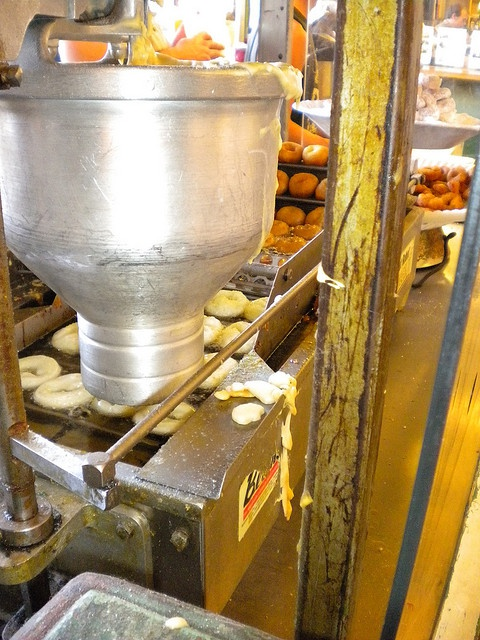Describe the objects in this image and their specific colors. I can see donut in tan and ivory tones, donut in tan, red, and maroon tones, donut in tan, red, and orange tones, donut in tan, orange, and brown tones, and donut in tan, red, maroon, and orange tones in this image. 